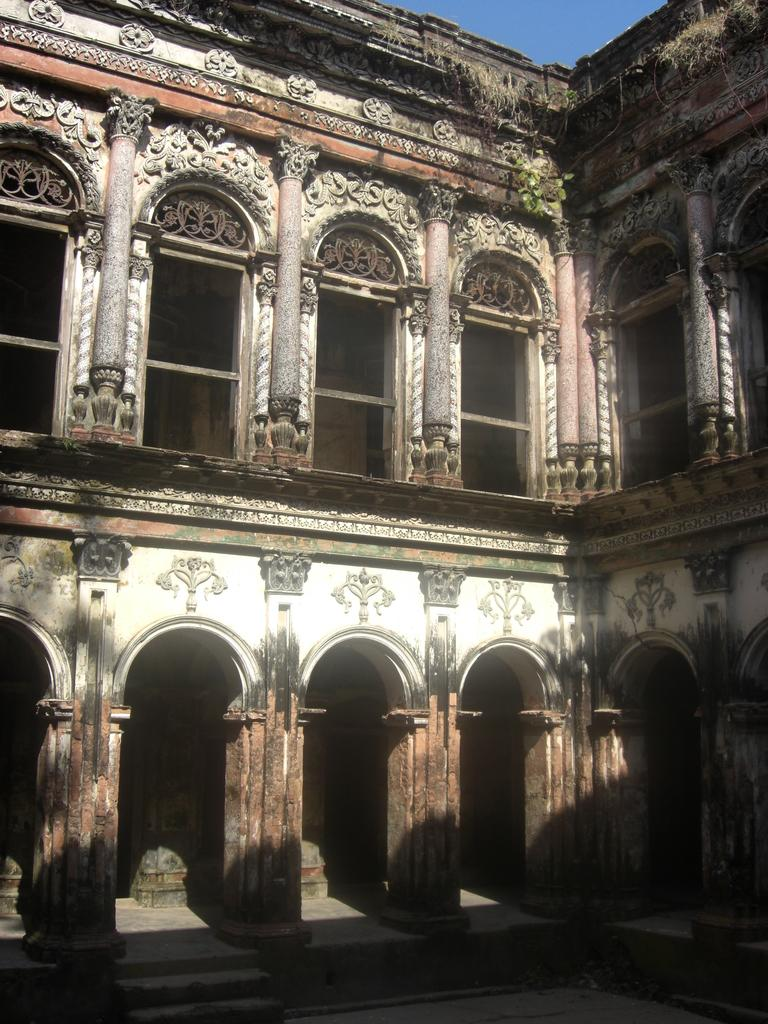What type of structure is present in the image? There is a building in the image. What architectural feature can be seen on the building? The building has pillars. What colors are used to paint the building? The building is in white and brown color. What can be seen in the background of the image? The sky is visible in the background of the image. How many cakes are placed on the vest in the image? There is no vest or cakes present in the image. 